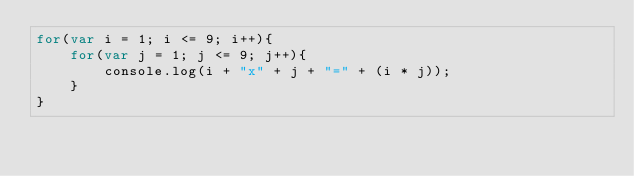Convert code to text. <code><loc_0><loc_0><loc_500><loc_500><_JavaScript_>for(var i = 1; i <= 9; i++){
    for(var j = 1; j <= 9; j++){
        console.log(i + "x" + j + "=" + (i * j));
    }
}</code> 